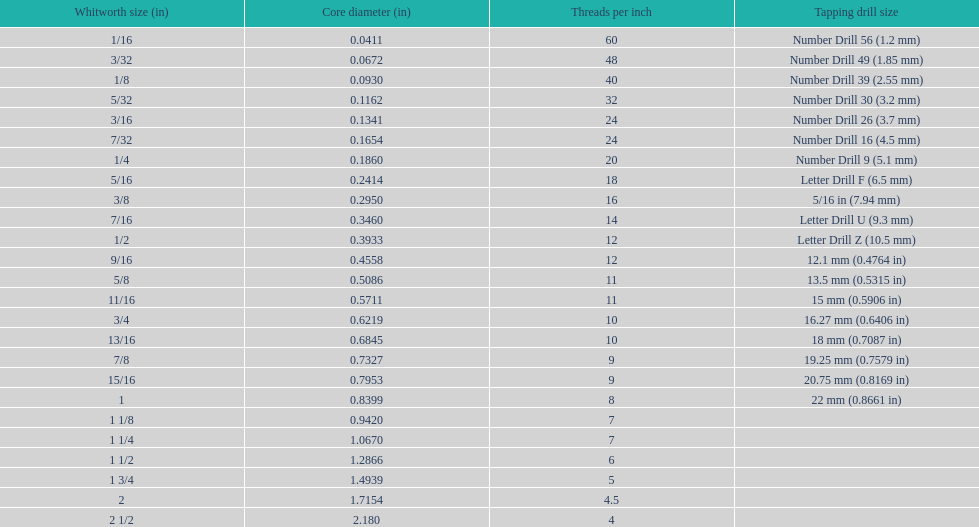How many threads per inch does a 9/16 have? 12. 